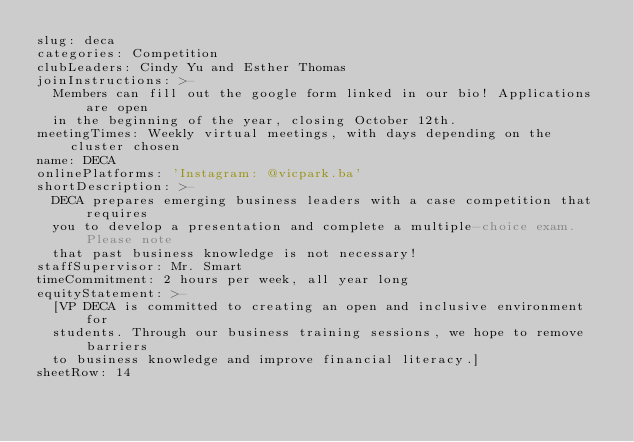<code> <loc_0><loc_0><loc_500><loc_500><_YAML_>slug: deca
categories: Competition
clubLeaders: Cindy Yu and Esther Thomas
joinInstructions: >-
  Members can fill out the google form linked in our bio! Applications are open
  in the beginning of the year, closing October 12th.
meetingTimes: Weekly virtual meetings, with days depending on the cluster chosen
name: DECA
onlinePlatforms: 'Instagram: @vicpark.ba'
shortDescription: >-
  DECA prepares emerging business leaders with a case competition that requires
  you to develop a presentation and complete a multiple-choice exam. Please note
  that past business knowledge is not necessary!
staffSupervisor: Mr. Smart
timeCommitment: 2 hours per week, all year long
equityStatement: >-
  [VP DECA is committed to creating an open and inclusive environment for
  students. Through our business training sessions, we hope to remove barriers
  to business knowledge and improve financial literacy.]
sheetRow: 14
</code> 